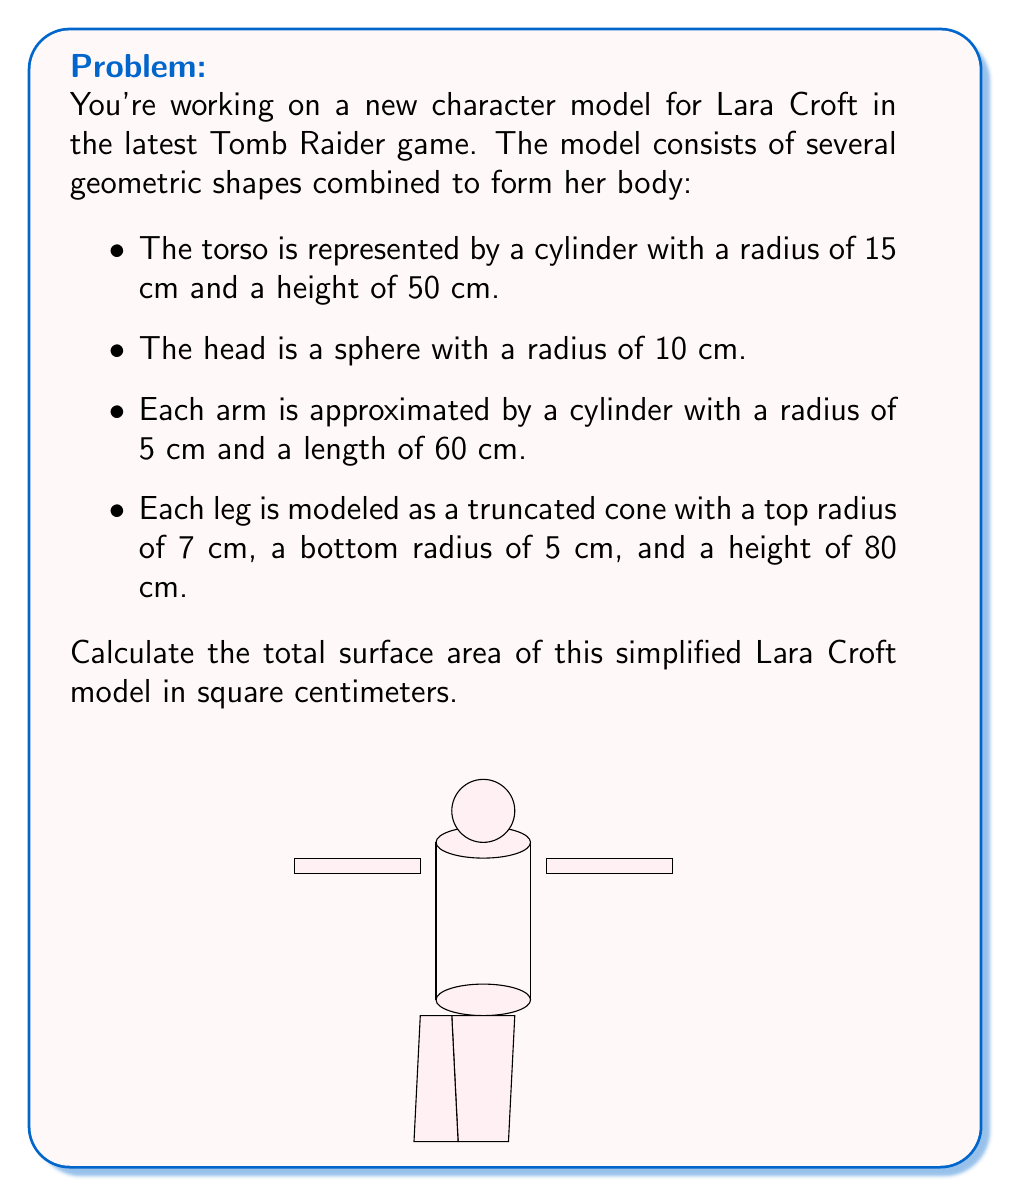Could you help me with this problem? Let's calculate the surface area of each part separately:

1. Torso (cylinder):
   Surface area = $2\pi r^2 + 2\pi rh$
   $$ A_{torso} = 2\pi(15^2) + 2\pi(15)(50) = 1413.72 + 4712.39 = 6126.11 \text{ cm}^2 $$

2. Head (sphere):
   Surface area = $4\pi r^2$
   $$ A_{head} = 4\pi(10^2) = 1256.64 \text{ cm}^2 $$

3. Arms (2 cylinders):
   Surface area of one arm = $2\pi r^2 + 2\pi rh$
   $$ A_{arm} = 2\pi(5^2) + 2\pi(5)(60) = 157.08 + 1884.96 = 2042.04 \text{ cm}^2 $$
   Total for both arms = $2 \times 2042.04 = 4084.08 \text{ cm}^2$

4. Legs (2 truncated cones):
   Surface area of one leg = $\pi(r_1 + r_2)\sqrt{h^2 + (r_1 - r_2)^2} + \pi r_1^2 + \pi r_2^2$
   $$ A_{leg} = \pi(7 + 5)\sqrt{80^2 + (7 - 5)^2} + \pi(7^2) + \pi(5^2) $$
   $$ = 12\pi\sqrt{6404} + 49\pi + 25\pi = 3016.59 + 232.48 = 3249.07 \text{ cm}^2 $$
   Total for both legs = $2 \times 3249.07 = 6498.14 \text{ cm}^2$

5. Total surface area:
   $$ A_{total} = A_{torso} + A_{head} + A_{arms} + A_{legs} $$
   $$ = 6126.11 + 1256.64 + 4084.08 + 6498.14 = 17964.97 \text{ cm}^2 $$
Answer: 17964.97 cm² 